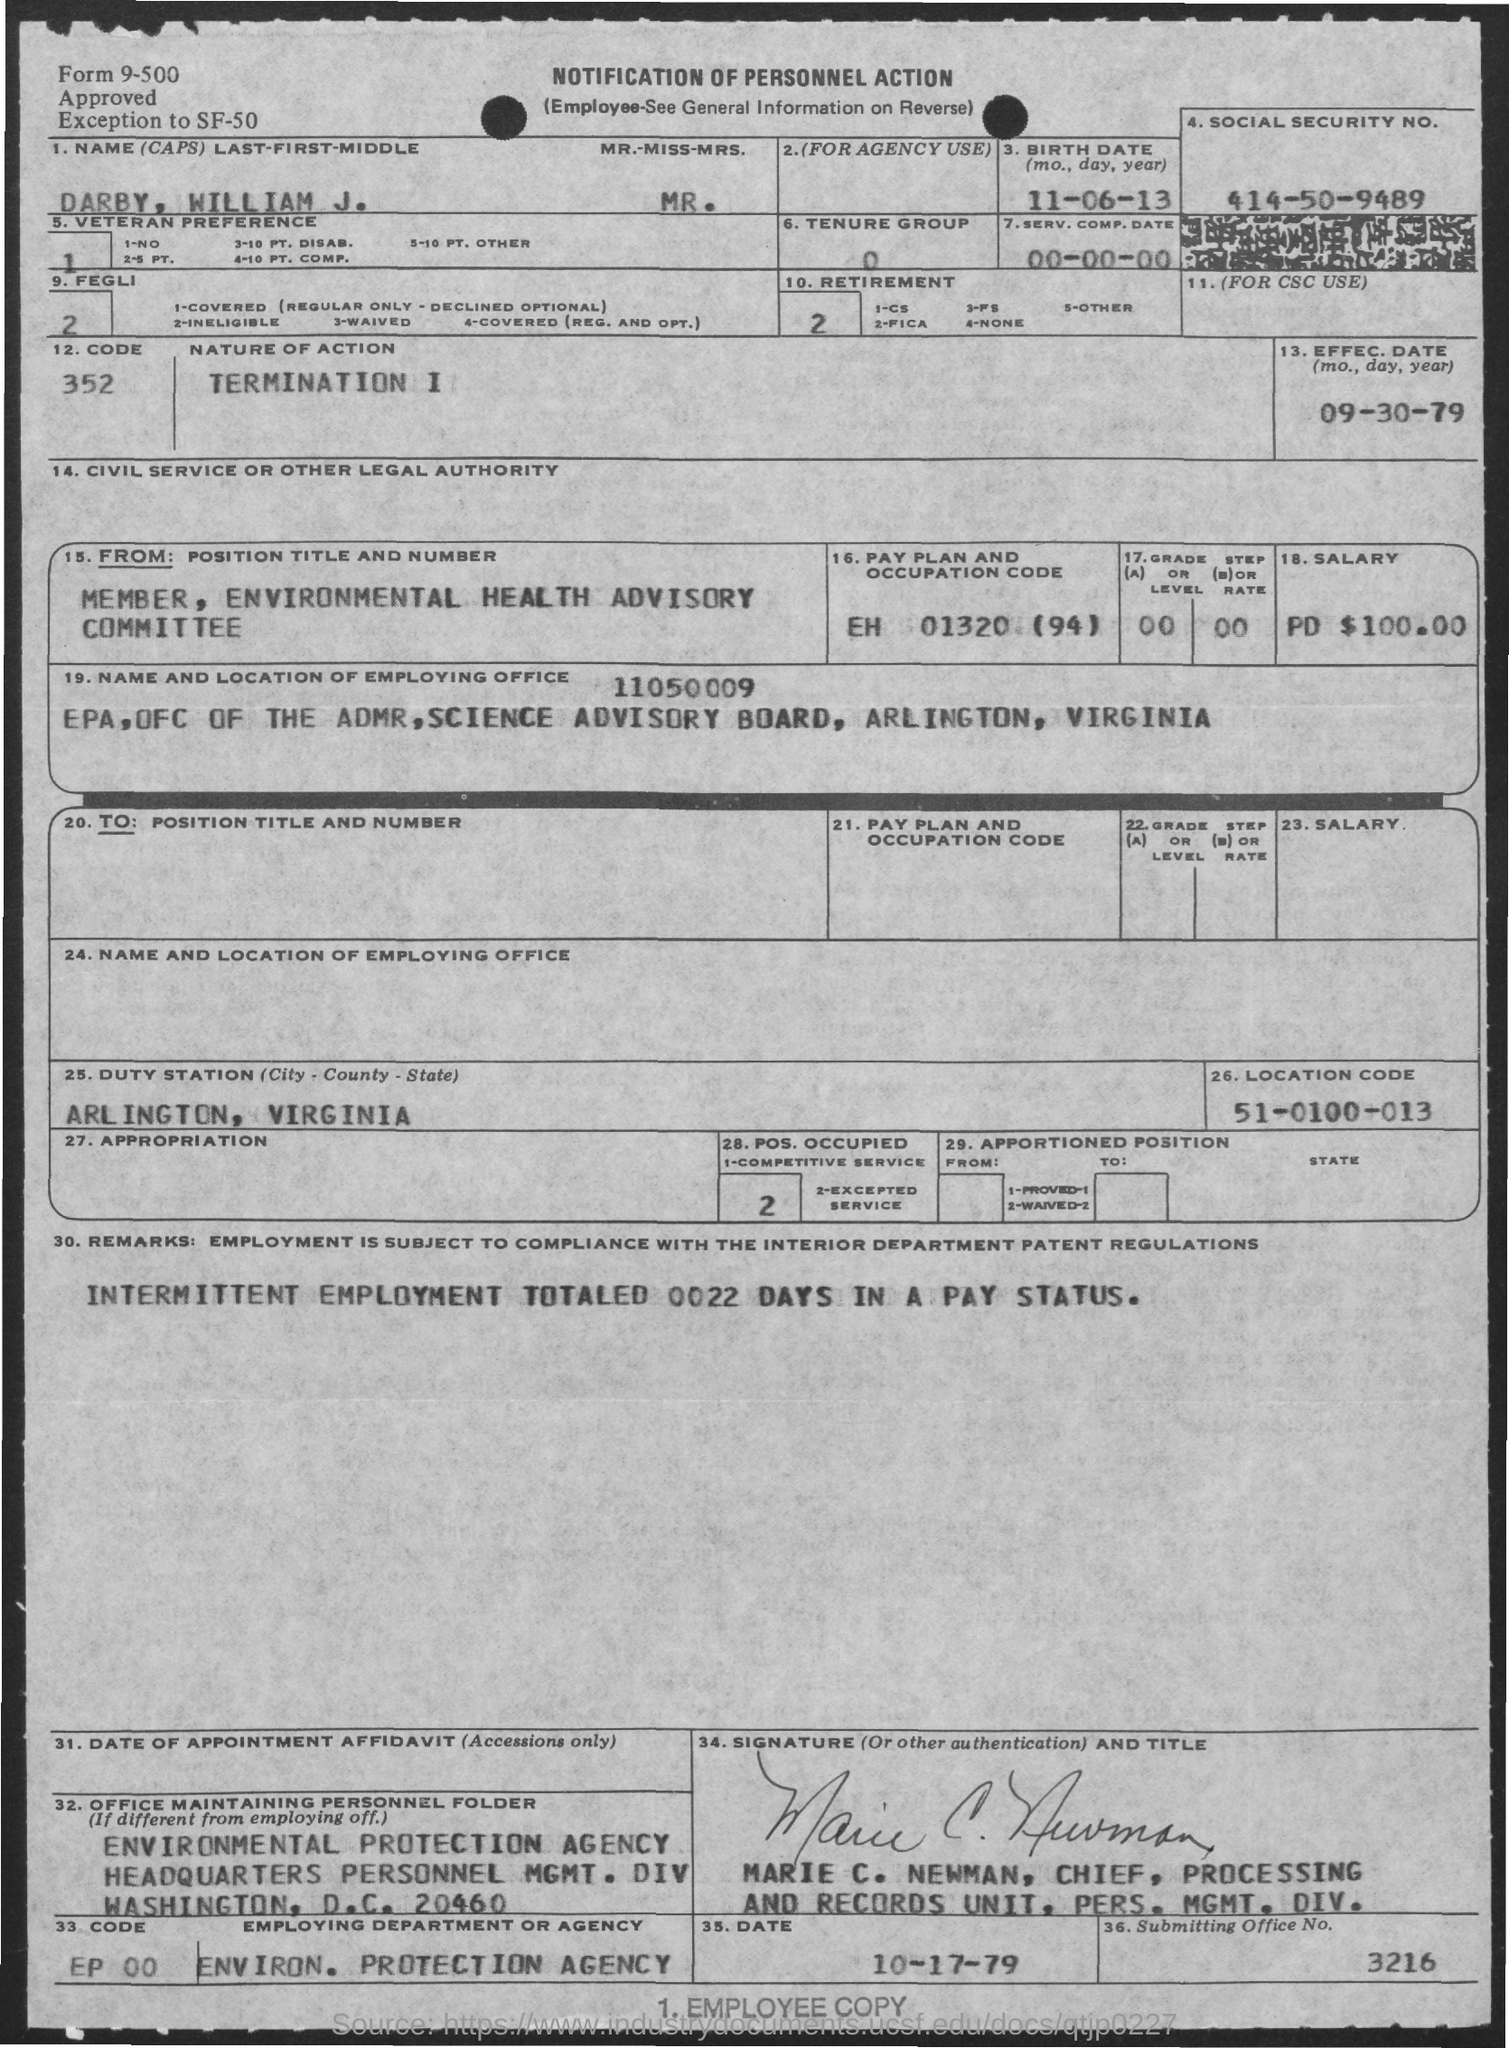What is social security no.?
Ensure brevity in your answer.  414-50-9489. What is the nature of action?
Your answer should be very brief. Termination I. What is the birth date?
Offer a very short reply. 11-06-13. What is the effective date?
Provide a succinct answer. 09-30-79. What is submitting office no.?
Make the answer very short. 3216. Who is chief, processing and records unit, pers. mgmt. div. ?
Your response must be concise. MARIE C. NEWMAN. What is the employing department or agency ?
Keep it short and to the point. Environ. Protection Agency. What is the pay plan and occupation code of darby. william j. ?
Your answer should be very brief. EH 01320 (94). 